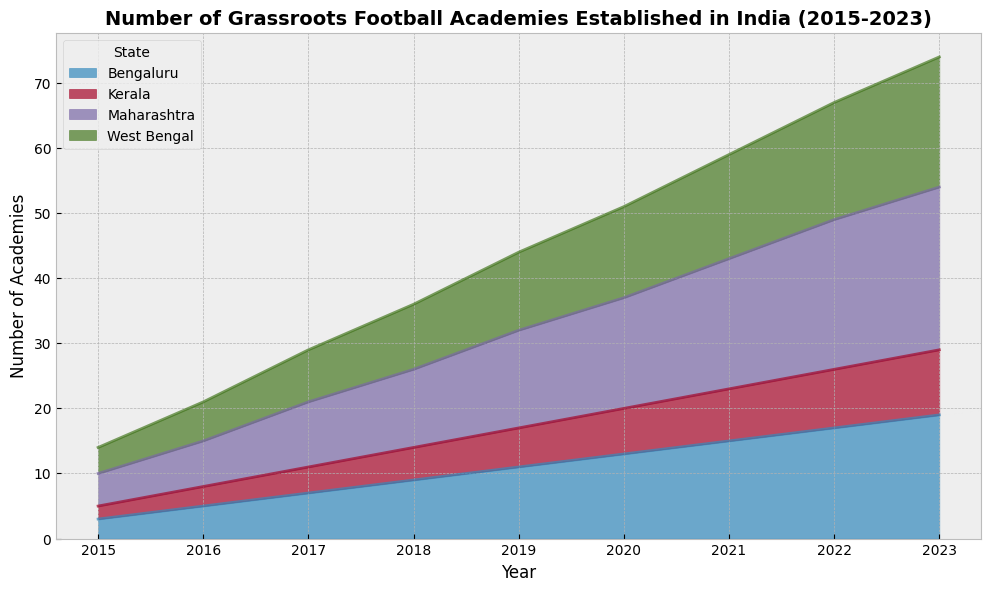Which state had the highest number of grassroots football academies in 2023? In the 2023 segment of the area chart, observe the topmost layer representing the state color with the greatest height. From the figure, Maharashtra clearly has the highest number.
Answer: Maharashtra How many total grassroots football academies were established in 2020 across all states? Identify the 2020 segment in the area chart, then sum the heights of all the states for that year. Maharashtra (17) + Bengaluru (13) + West Bengal (14) + Kerala (7) = 51 academies.
Answer: 51 Which year saw the largest increase in grassroots football academies in West Bengal? Compare the heights of the West Bengal segments for each pair of consecutive years and identify the largest growth. From 2016 to 2017, there is an increase from 6 to 8 academies, the largest for any consecutive years for West Bengal.
Answer: 2017 In which year did Kerala have exactly 10 grassroots football academies? Find the year labeled on the x-axis where the height of the green segment representing Kerala reaches 10. In the figure, this is observed in the year 2023.
Answer: 2023 What is the total number of grassroots football academies established in Maharashtra from 2015 to 2022? Sum the number of academies in Maharashtra over the given years: 5 (2015) + 7 (2016) + 10 (2017) + 12 (2018) + 15 (2019) + 17 (2020) + 20 (2021) + 23 (2022) = 109 academies.
Answer: 109 Which state showed the most consistent growth in the number of academies established from 2015 to 2023? Evaluate the states by visually inspecting the uniformity of the increase in the height of their segments across the years. Maharashtra consistently grows each year, without any major fluctuations, indicating the most consistent growth.
Answer: Maharashtra How does the number of academies in Bengaluru in 2020 compare to Kerala in the same year? Examine the height of the segments for Bengaluru (blue) and Kerala (green) for the year 2020. Bengaluru has 13 academies, while Kerala has 7 academies. Bengaluru has more academies than Kerala in 2020.
Answer: Bengaluru has more What is the difference in the number of academies between West Bengal and Kerala in 2022? Find the height of segments for West Bengal and Kerala in 2022. West Bengal has 18 academies and Kerala has 9 academies. The difference is 18 - 9 = 9 academies.
Answer: 9 academies Which two consecutive years saw the biggest increase in total number of academies across all states? Calculate the total number of academies for each year and compare consecutive years to find the biggest increase. Detailed comparison shows between 2021 (59) and 2022 (67) there is the largest increase of 67 - 59 = 8 academies added.
Answer: Between 2021 and 2022 